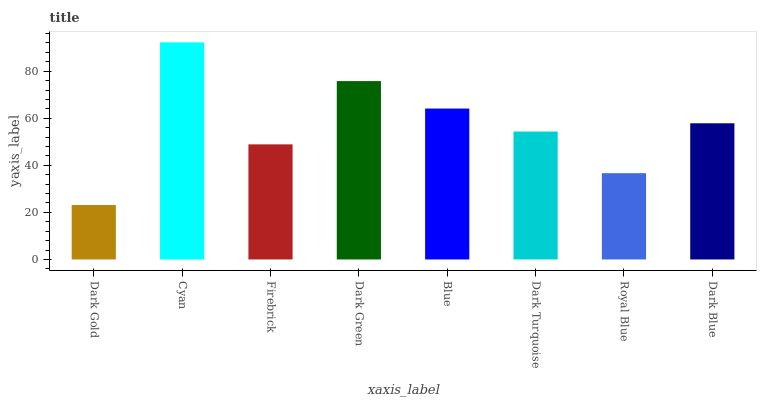Is Firebrick the minimum?
Answer yes or no. No. Is Firebrick the maximum?
Answer yes or no. No. Is Cyan greater than Firebrick?
Answer yes or no. Yes. Is Firebrick less than Cyan?
Answer yes or no. Yes. Is Firebrick greater than Cyan?
Answer yes or no. No. Is Cyan less than Firebrick?
Answer yes or no. No. Is Dark Blue the high median?
Answer yes or no. Yes. Is Dark Turquoise the low median?
Answer yes or no. Yes. Is Firebrick the high median?
Answer yes or no. No. Is Dark Blue the low median?
Answer yes or no. No. 